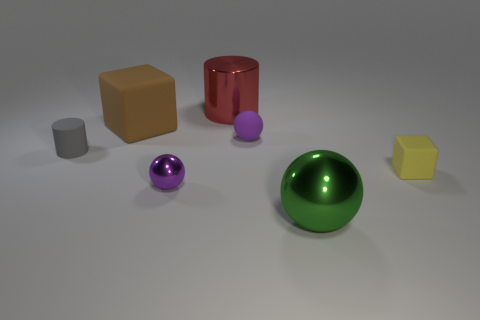Are there fewer large red metal objects that are to the right of the tiny yellow matte thing than metal balls to the left of the red metal cylinder?
Offer a terse response. Yes. What material is the other sphere that is the same color as the tiny matte ball?
Keep it short and to the point. Metal. Is there any other thing that is the same shape as the small purple shiny thing?
Offer a very short reply. Yes. There is a cylinder right of the tiny gray cylinder; what is it made of?
Your answer should be compact. Metal. There is a yellow matte block; are there any green spheres on the left side of it?
Offer a terse response. Yes. There is a big red metal thing; what shape is it?
Your answer should be compact. Cylinder. How many things are big metallic objects that are in front of the large red cylinder or small red balls?
Ensure brevity in your answer.  1. What number of other things are the same color as the tiny shiny ball?
Give a very brief answer. 1. There is a small matte sphere; does it have the same color as the tiny ball in front of the tiny gray rubber object?
Provide a short and direct response. Yes. The other small object that is the same shape as the brown object is what color?
Keep it short and to the point. Yellow. 